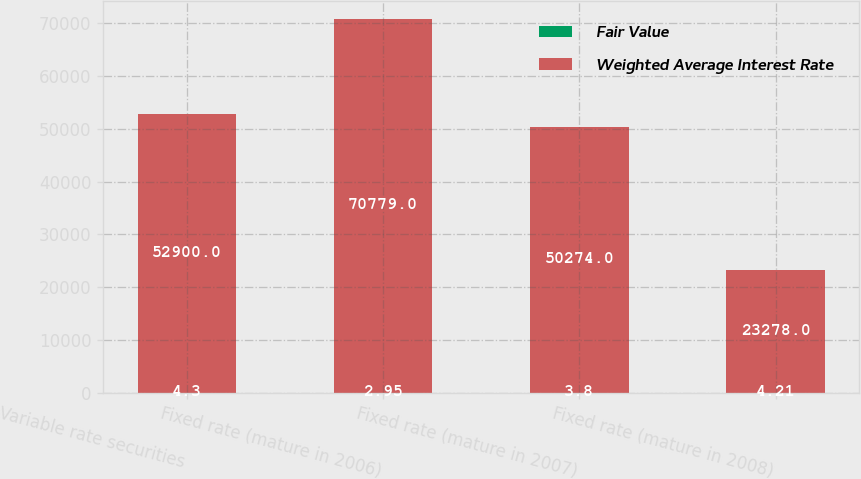<chart> <loc_0><loc_0><loc_500><loc_500><stacked_bar_chart><ecel><fcel>Variable rate securities<fcel>Fixed rate (mature in 2006)<fcel>Fixed rate (mature in 2007)<fcel>Fixed rate (mature in 2008)<nl><fcel>Fair Value<fcel>4.3<fcel>2.95<fcel>3.8<fcel>4.21<nl><fcel>Weighted Average Interest Rate<fcel>52900<fcel>70779<fcel>50274<fcel>23278<nl></chart> 